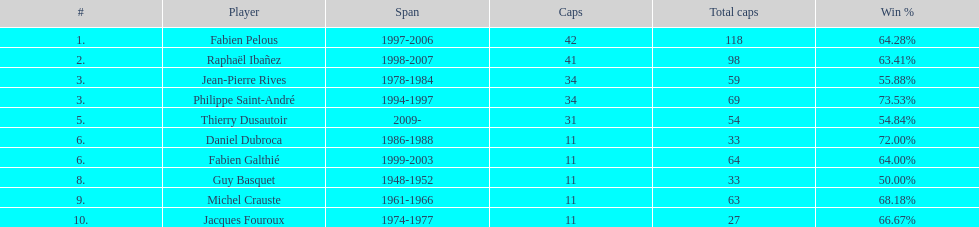How many players possess time spans over three years? 6. 